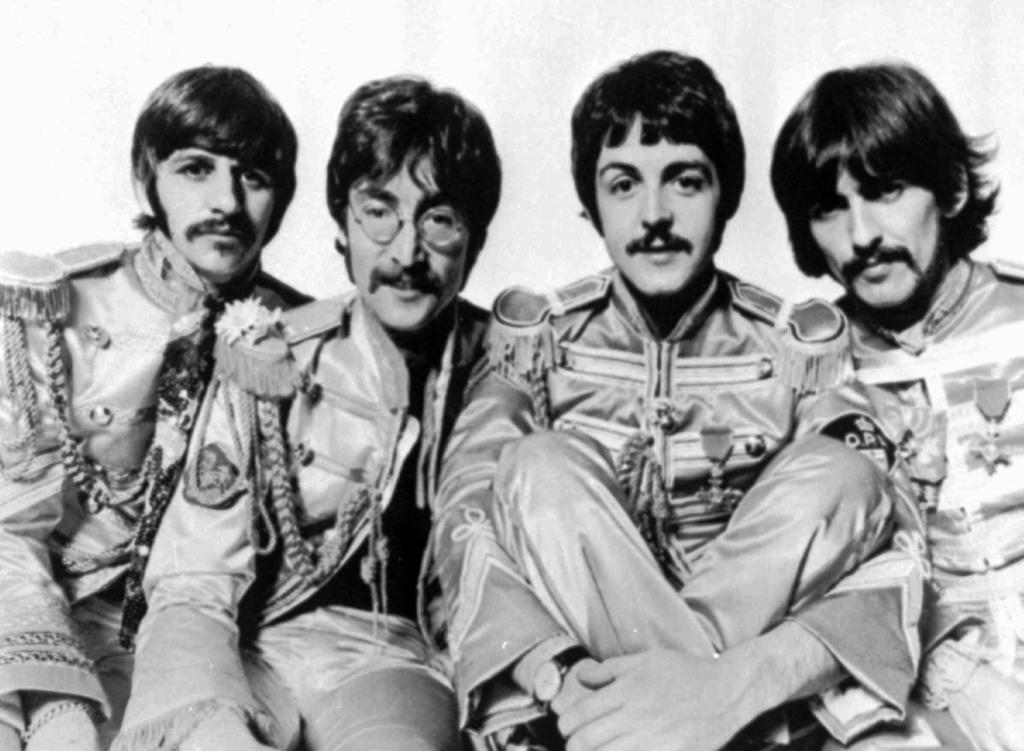What is the color scheme of the image? The image is black and white. How many people are in the image? There are four men in the image. What are the men wearing? The men are wearing the same dresses. What are the men doing in the image? The men are sitting and smiling. What is the purpose of the men's poses in the image? The men are posing for the picture. What type of lock can be seen in the image? There is no lock present in the image. What brand of toothpaste is the man using in the image? There is no toothpaste or man using toothpaste in the image. 